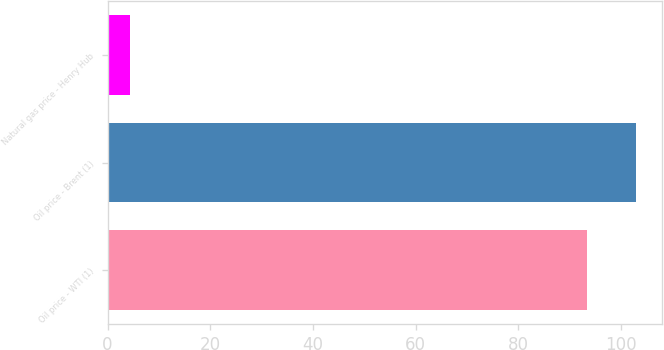<chart> <loc_0><loc_0><loc_500><loc_500><bar_chart><fcel>Oil price - WTI (1)<fcel>Oil price - Brent (1)<fcel>Natural gas price - Henry Hub<nl><fcel>93.37<fcel>102.84<fcel>4.39<nl></chart> 